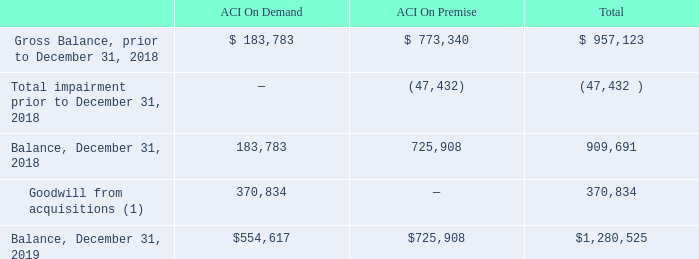Goodwill and Other Intangibles
In accordance with ASC 350, Intangibles – Goodwill and Other, the Company assesses goodwill for impairment annually during the fourth quarter of its fiscal year using October 1 balances or when there is evidence that events or changes in circumstances indicate that the carrying amount of the asset may not be recovered. The Company evaluates goodwill at the reporting unit level using the discounted cash flow valuation model and allocates goodwill to these reporting units using a relative fair value approach. During this assessment, management relies on a number of factors, including operating results, business plans, and anticipated future cash flows. The Company has identified its reportable segments, ACI On Premise and ACI On Demand, as the reporting units.
The key assumptions used in the discounted cash flow valuation model include discount rates, growth rates, cash flow projections and terminal value rates. Discount rates, growth rates, and cash flow projections are the most sensitive and susceptible to change, as they require significant management judgment. Discount rates are determined by using a weighted average cost of capital (“WACC”). The WACC considers market and industry data as well as company-specific risk factors. Operational management, considering industry and company-specific historical and projected data, develops growth rates and cash flow projections for each  flow estimates beyond the last projected period, assuming a constant WACC and low, long-term growth rates. If the recoverability test indicates potential impairment, the Company calculates an implied fair value of goodwill for the reporting unit. The implied fair value of goodwill is determined in a manner similar to how goodwill is calculated in a business combination. If the implied fair value of goodwill exceeds the carrying value of goodwill assigned to the reporting unit, there is no impairment. If the carrying value of goodwill assigned to the reporting unit exceeds the implied fair value of the goodwill, an impairment charge is recorded to write down the carrying value. The calculated fair value substantially exceeded the current carrying value for all reporting units for all periods.
Changes in the carrying amount of goodwill attributable to each reporting unit during the year ended December 31, 2019, were as follows (in thousands):
(1) Goodwill from acquisitions relates to the goodwill recorded for the acquisition of E Commerce Group Products, Inc. ("ECG"), along with ECG's subsidiary, Speedpay, Inc. (collectively referred to as "Speedpay") and Walletron, Inc. ("Walletron"), as discussed in Note 3, Acquisition. The purchase price allocations for Speedpay and Walletron are preliminary as of December 31, 2019, and are subject to future changes during the maximum one-year measurement period.
Other intangible assets, which include customer relationships and trademarks and trade names, are amortized using the straight-line method over periods ranging from three years to 20 years. The Company reviews its other intangible assets for impairment whenever events or changes in circumstances indicate that the carrying amount may not be recoverable.
How did the company amortize other intangible assets? Using the straight-line method over periods ranging from three years to 20 years. What was the balance of ACI On demand in 2019?
Answer scale should be: thousand. $554,617. What was the total balance in 2019?
Answer scale should be: thousand. $1,280,525. What was the change in balance of ACI on demand between 2018 and 2019?
Answer scale should be: thousand. $554,617-183,783
Answer: 370834. What was the change in total balance between 2018 and 2019?
Answer scale should be: thousand. $1,280,525-909,691
Answer: 370834. What percentage of total balance consists of ACI on Demand in 2019?
Answer scale should be: percent. $554,617/$1,280,525
Answer: 43.31. 